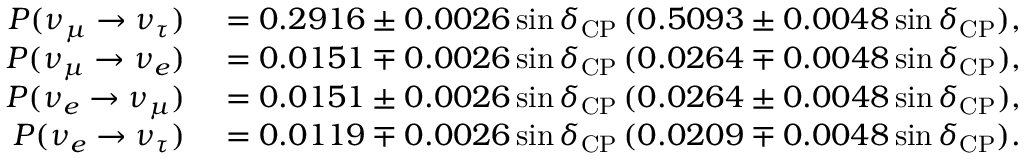Convert formula to latex. <formula><loc_0><loc_0><loc_500><loc_500>\begin{array} { r l } { P ( \nu _ { \mu } \to \nu _ { \tau } ) } & = 0 . 2 9 1 6 \pm 0 . 0 0 2 6 \sin \delta _ { C P } \, ( 0 . 5 0 9 3 \pm 0 . 0 0 4 8 \sin \delta _ { C P } ) , } \\ { P ( \nu _ { \mu } \rightarrow \nu _ { e } ) } & = 0 . 0 1 5 1 \mp 0 . 0 0 2 6 \sin \delta _ { C P } \, ( 0 . 0 2 6 4 \mp 0 . 0 0 4 8 \sin \delta _ { C P } ) , } \\ { P ( \nu _ { e } \rightarrow \nu _ { \mu } ) } & = 0 . 0 1 5 1 \pm 0 . 0 0 2 6 \sin \delta _ { C P } \, ( 0 . 0 2 6 4 \pm 0 . 0 0 4 8 \sin \delta _ { C P } ) , } \\ { P ( \nu _ { e } \rightarrow \nu _ { \tau } ) } & = 0 . 0 1 1 9 \mp 0 . 0 0 2 6 \sin \delta _ { C P } \, ( 0 . 0 2 0 9 \mp 0 . 0 0 4 8 \sin \delta _ { C P } ) . } \end{array}</formula> 